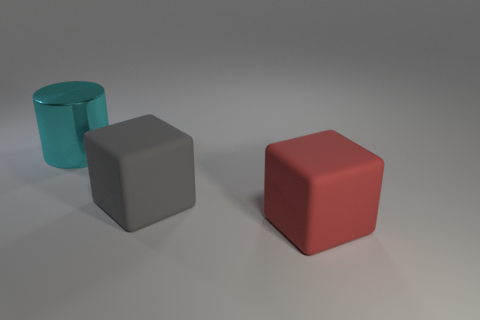Add 1 cyan cylinders. How many objects exist? 4 Subtract all cylinders. How many objects are left? 2 Add 1 matte things. How many matte things exist? 3 Subtract 0 green balls. How many objects are left? 3 Subtract all red matte things. Subtract all matte things. How many objects are left? 0 Add 3 big matte cubes. How many big matte cubes are left? 5 